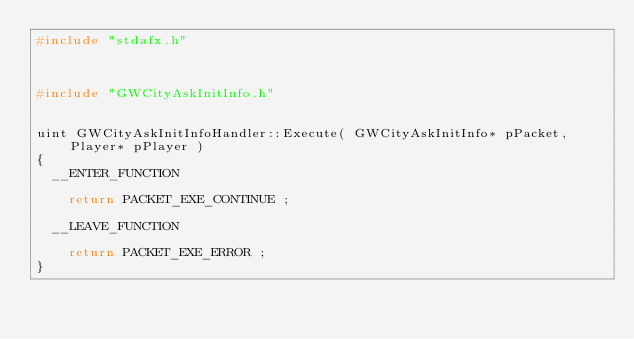Convert code to text. <code><loc_0><loc_0><loc_500><loc_500><_C++_>#include "stdafx.h"



#include "GWCityAskInitInfo.h"


uint GWCityAskInitInfoHandler::Execute( GWCityAskInitInfo* pPacket, Player* pPlayer )
{
	__ENTER_FUNCTION

		return PACKET_EXE_CONTINUE ;

	__LEAVE_FUNCTION

		return PACKET_EXE_ERROR ;
}
</code> 